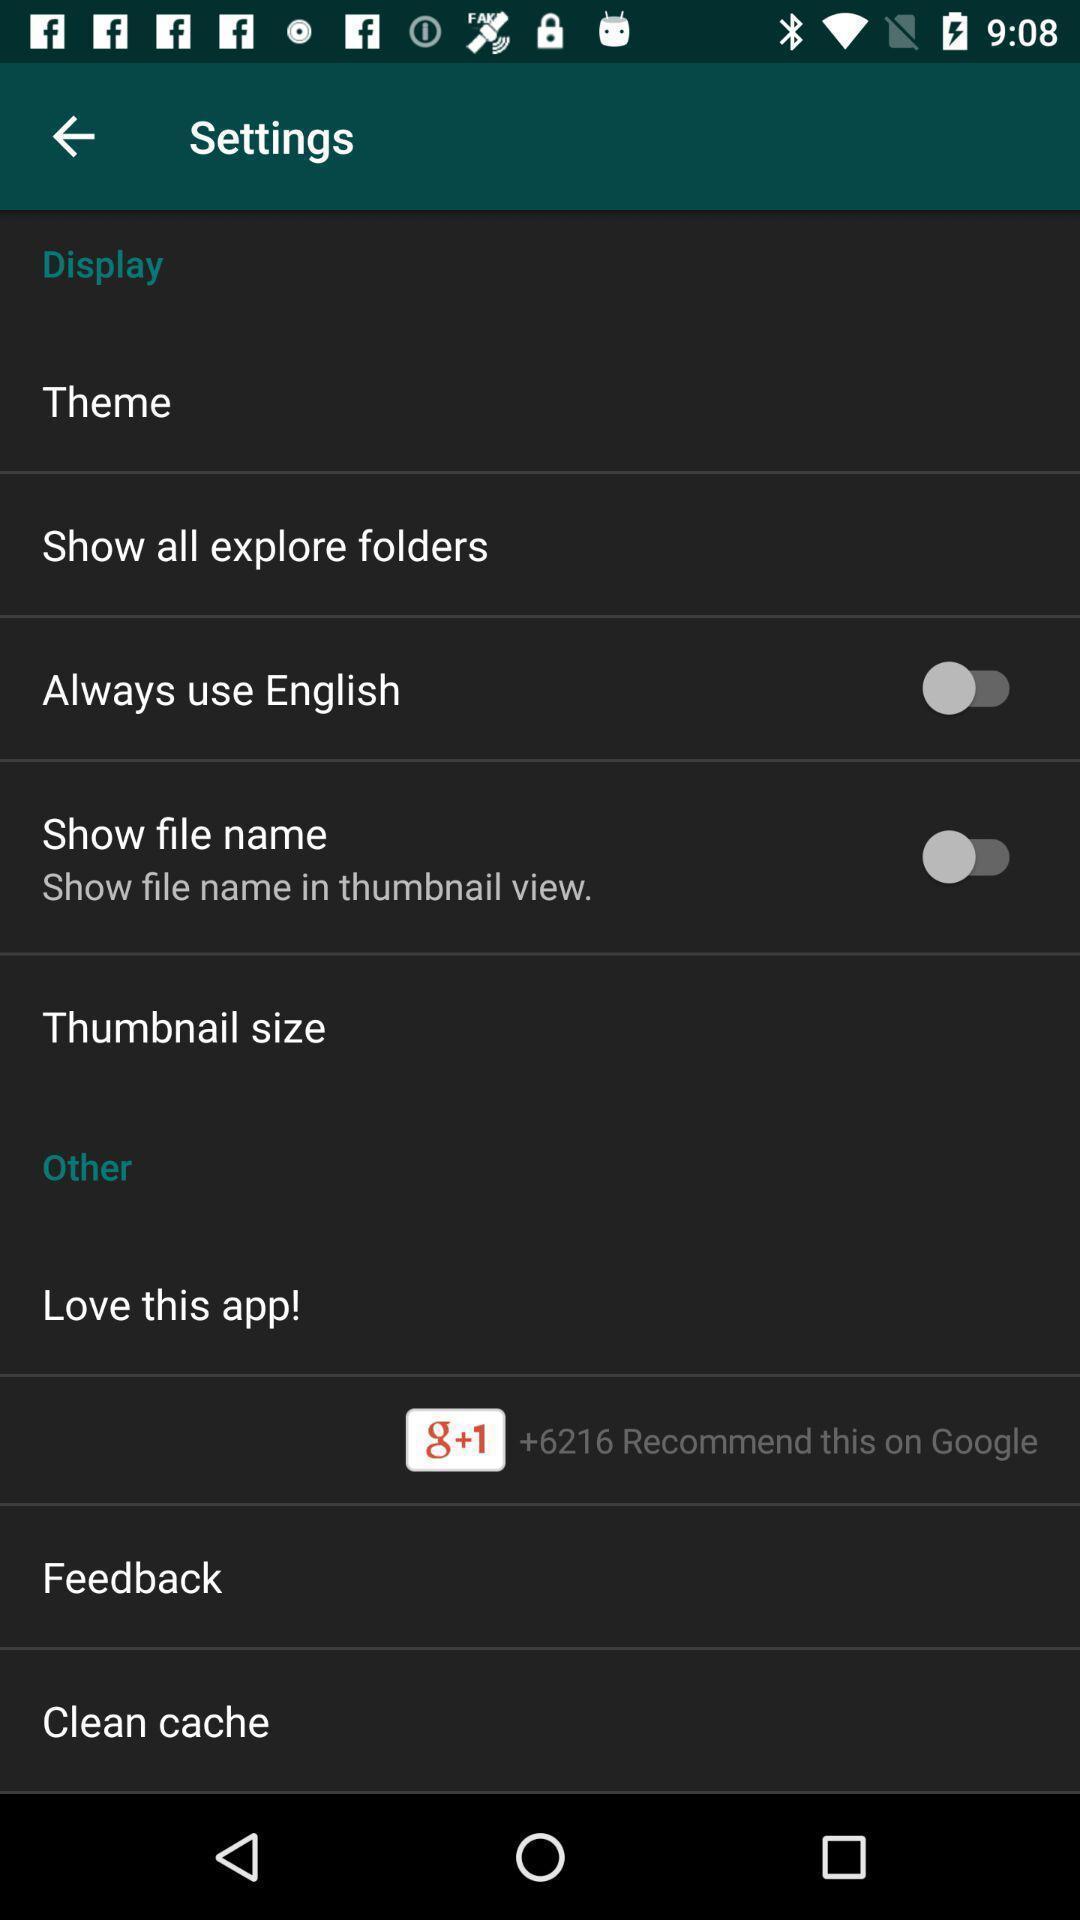What can you discern from this picture? Page displaying different setting options available. 